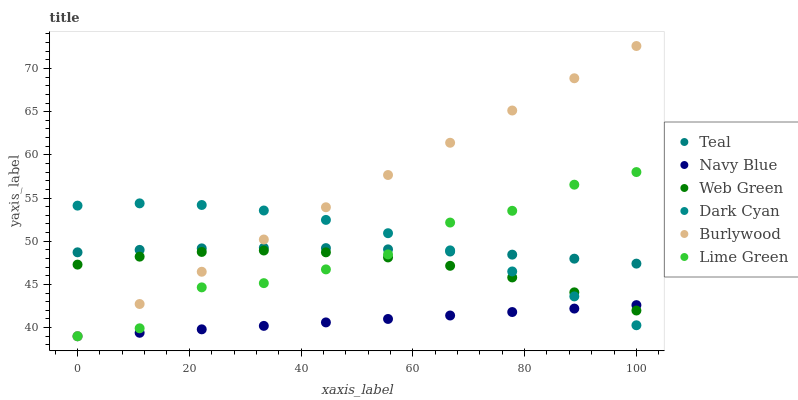Does Navy Blue have the minimum area under the curve?
Answer yes or no. Yes. Does Burlywood have the maximum area under the curve?
Answer yes or no. Yes. Does Web Green have the minimum area under the curve?
Answer yes or no. No. Does Web Green have the maximum area under the curve?
Answer yes or no. No. Is Navy Blue the smoothest?
Answer yes or no. Yes. Is Lime Green the roughest?
Answer yes or no. Yes. Is Web Green the smoothest?
Answer yes or no. No. Is Web Green the roughest?
Answer yes or no. No. Does Burlywood have the lowest value?
Answer yes or no. Yes. Does Web Green have the lowest value?
Answer yes or no. No. Does Burlywood have the highest value?
Answer yes or no. Yes. Does Web Green have the highest value?
Answer yes or no. No. Is Web Green less than Teal?
Answer yes or no. Yes. Is Teal greater than Web Green?
Answer yes or no. Yes. Does Web Green intersect Navy Blue?
Answer yes or no. Yes. Is Web Green less than Navy Blue?
Answer yes or no. No. Is Web Green greater than Navy Blue?
Answer yes or no. No. Does Web Green intersect Teal?
Answer yes or no. No. 